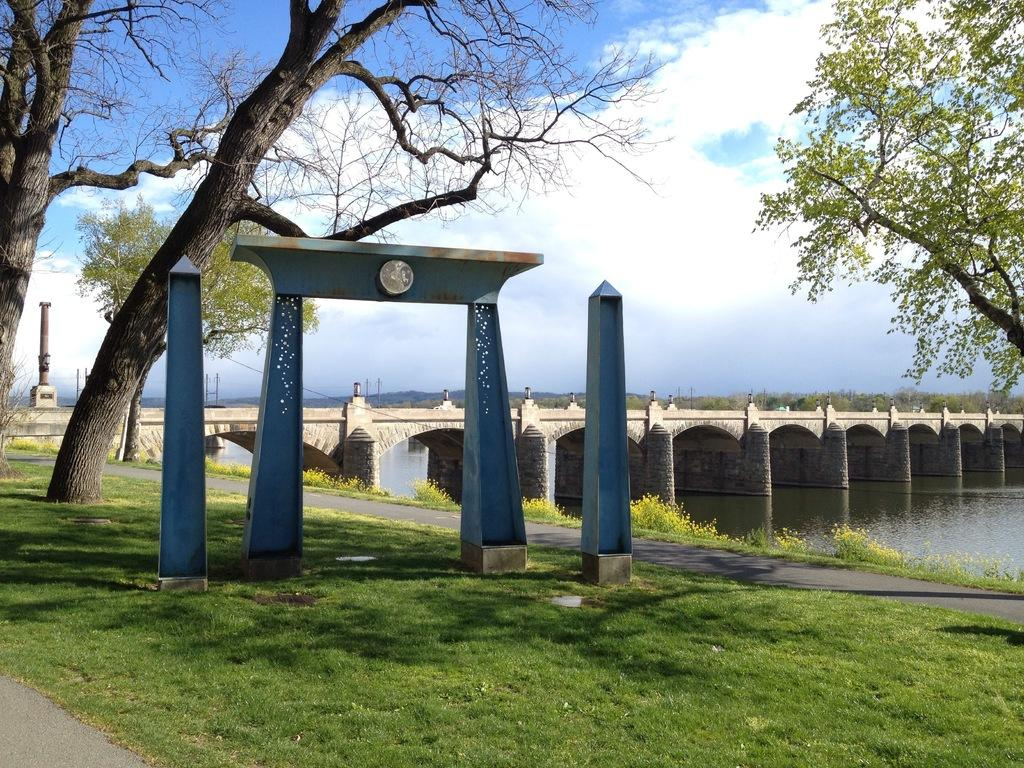What structures can be seen in the image? There are poles, an arch on the ground, and a bridge in the image. What type of vegetation is present in the image? There are trees in the image. What can be seen under the bridge? There is water visible under the bridge. What is visible in the background of the image? The sky is visible in the background of the image. Where is the queen standing in the image? There is no queen present in the image. What type of cannon is located near the bridge? There is no cannon present in the image. 